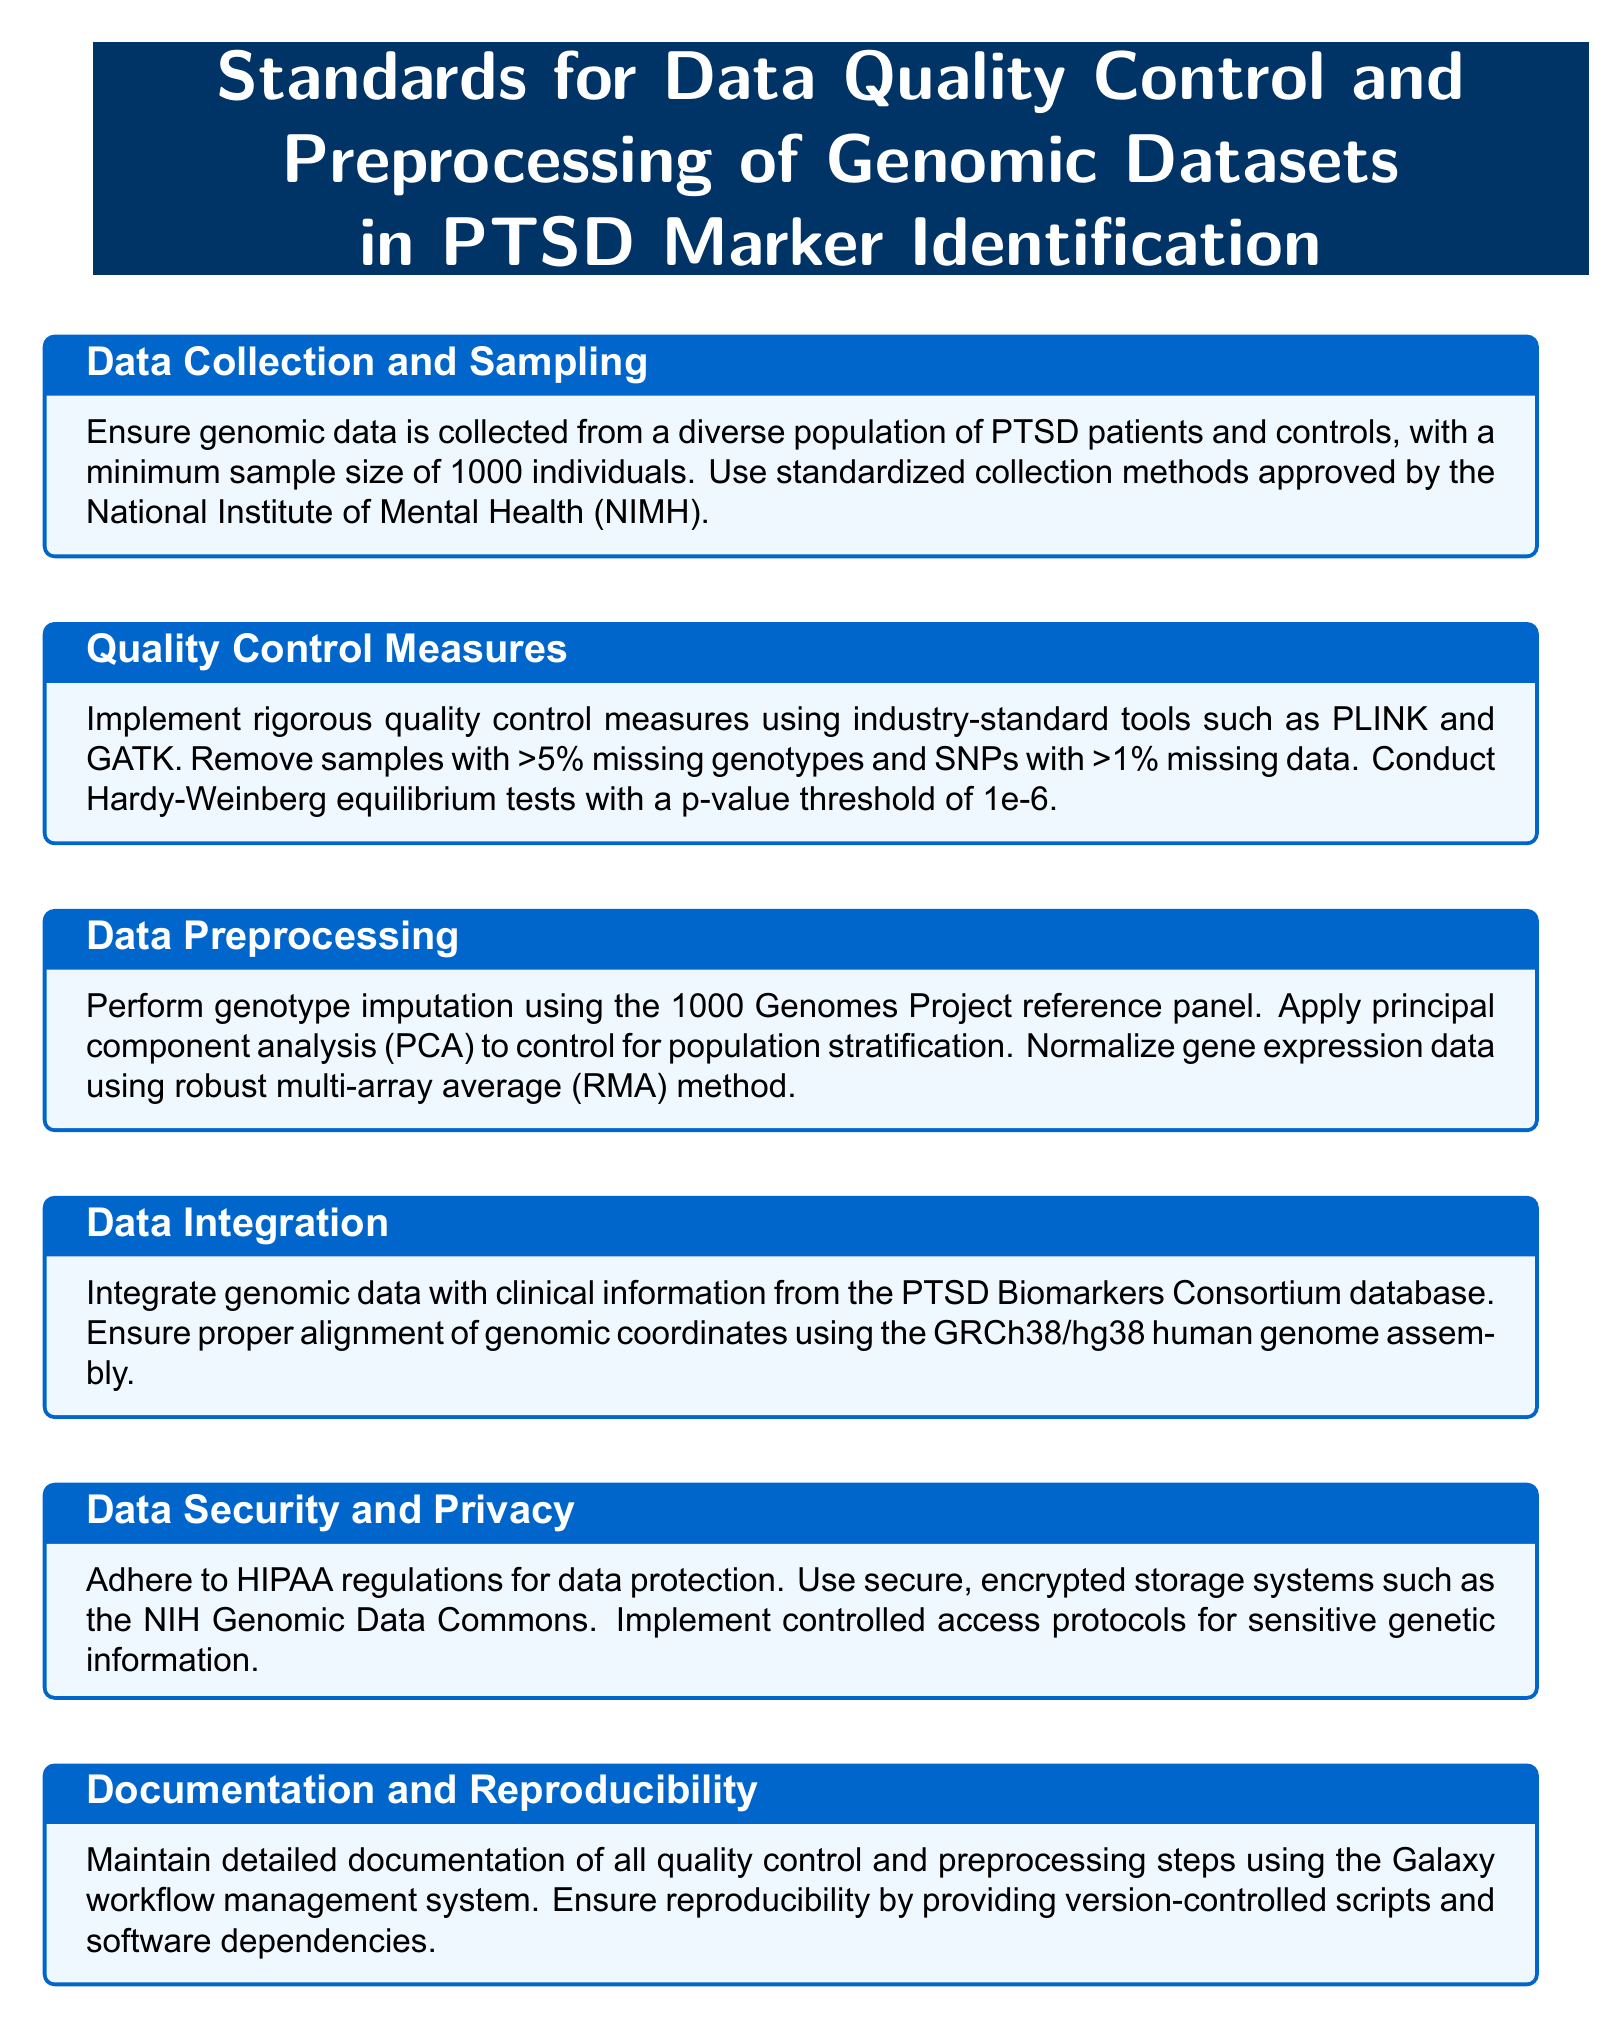What is the minimum sample size required? The minimum sample size is specified in the data collection section, which requires a minimum of 1000 individuals.
Answer: 1000 individuals What tool is suggested for genotype imputation? The document mentions using the 1000 Genomes Project reference panel for genotype imputation in the data preprocessing section.
Answer: 1000 Genomes Project What is the p-value threshold for Hardy-Weinberg equilibrium tests? The quality control measures specify the p-value threshold for Hardy-Weinberg equilibrium tests as 1e-6.
Answer: 1e-6 What method is required for normalizing gene expression data? The data preprocessing section states that the robust multi-array average method should be used for normalization.
Answer: robust multi-array average What is the main focus of the document? The document sets standards for data quality control and preprocessing specifically related to genomic datasets in PTSD marker identification.
Answer: Standards for Data Quality Control Which system is recommended for secure data storage? The document refers to the NIH Genomic Data Commons as a recommended secure, encrypted storage system.
Answer: NIH Genomic Data Commons What should be maintained for reproducibility? The documentation section emphasizes that detailed records of all quality control and preprocessing steps should be maintained for ensuring reproducibility.
Answer: Detailed documentation What assembly should genomic coordinates be aligned with? The document states that genomic coordinates should be aligned using the GRCh38/hg38 human genome assembly.
Answer: GRCh38/hg38 What regulatory standards must be adhered to for data protection? The document mentions that HIPAA regulations must be followed for data protection in the context of data security and privacy.
Answer: HIPAA regulations 